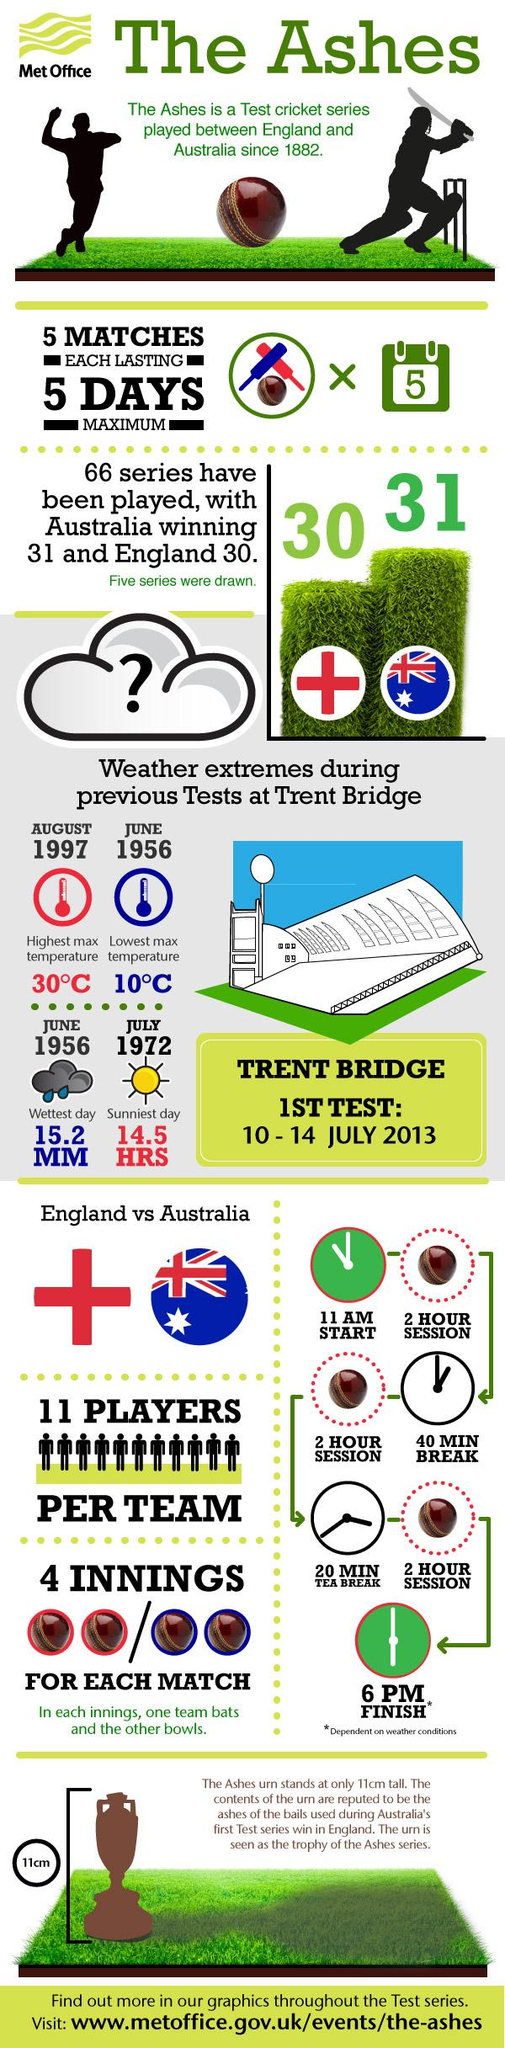Highlight a few significant elements in this photo. The weather was recorded at Trent Bridge. In August 1997, the highest temperature was recorded. It is not clear what you are asking. Can you please provide more context or clarify your question? In a test match, each team bowls a total of two innings. In a test match, each team bats for a maximum of two innings. 